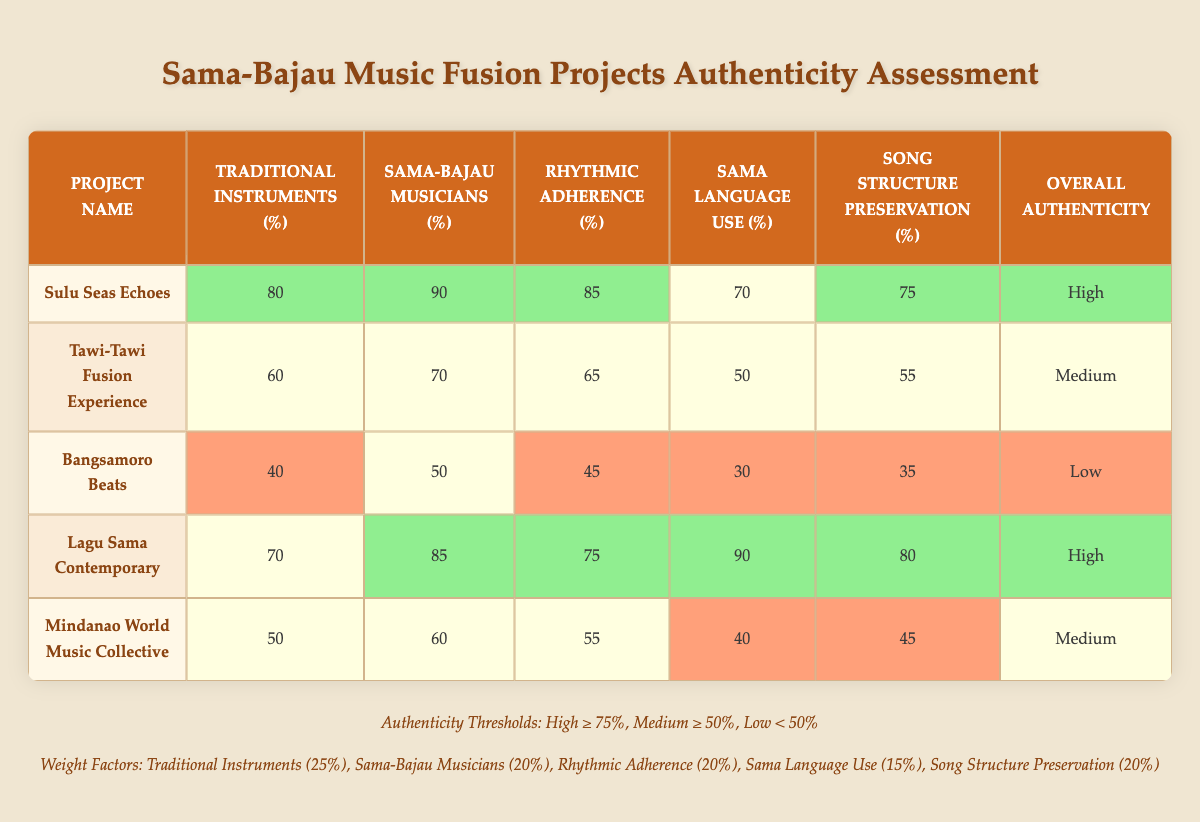What is the overall authenticity rating of "Sulu Seas Echoes"? The overall authenticity rating for "Sulu Seas Echoes" is listed in the last column of the corresponding row, which shows "High" next to the project name.
Answer: High Which project has the highest percentage of traditional instruments used? By examining the "Traditional Instruments (%)" column, "Sulu Seas Echoes" has the highest value at 80%, compared to the other projects.
Answer: Sulu Seas Echoes What is the average percentage of Sama-Bajau musicians involved across all projects? To find the average, sum the percentages of the "Sama-Bajau Musicians (%)" column: (90 + 70 + 50 + 85 + 60) = 355. Then, divide by the number of projects, which is 5, resulting in an average of 355/5 = 71.
Answer: 71 Does "Bangsamoro Beats" meet the medium authenticity threshold? Checking the overall authenticity rating for "Bangsamoro Beats," which is shown as "Low," indicates it does not meet the medium threshold (≥ 50%).
Answer: No What is the difference in rhythmic adherence percentage between "Lagu Sama Contemporary" and "Bangsamoro Beats"? The rhythmic adherence percentage for "Lagu Sama Contemporary" is 75%, while for "Bangsamoro Beats," it is 45%. The difference is calculated as 75 - 45 = 30.
Answer: 30 Which project uses the Sama language in its lyrics the most? Looking at the "Sama Language Use (%)" column, "Lagu Sama Contemporary" has the highest percentage of 90%.
Answer: Lagu Sama Contemporary Do any projects have low preservation of traditional song structures? By checking the "Song Structure Preservation (%)" column for values below 50%, we see that both "Bangsamoro Beats" (35%) and "Mindanao World Music Collective" (45%) qualify as low.
Answer: Yes How many projects have high involvement of Sama-Bajau musicians? Counting the rows where "Sama-Bajau Musicians (%)" is greater than or equal to 75%, "Sulu Seas Echoes" (90%) and "Lagu Sama Contemporary" (85%) both qualify, totaling 2 projects.
Answer: 2 What percentage of traditional instruments is used in "Tawi-Tawi Fusion Experience"? The "Traditional Instruments (%)" for "Tawi-Tawi Fusion Experience" shows as 60% in the corresponding row.
Answer: 60 